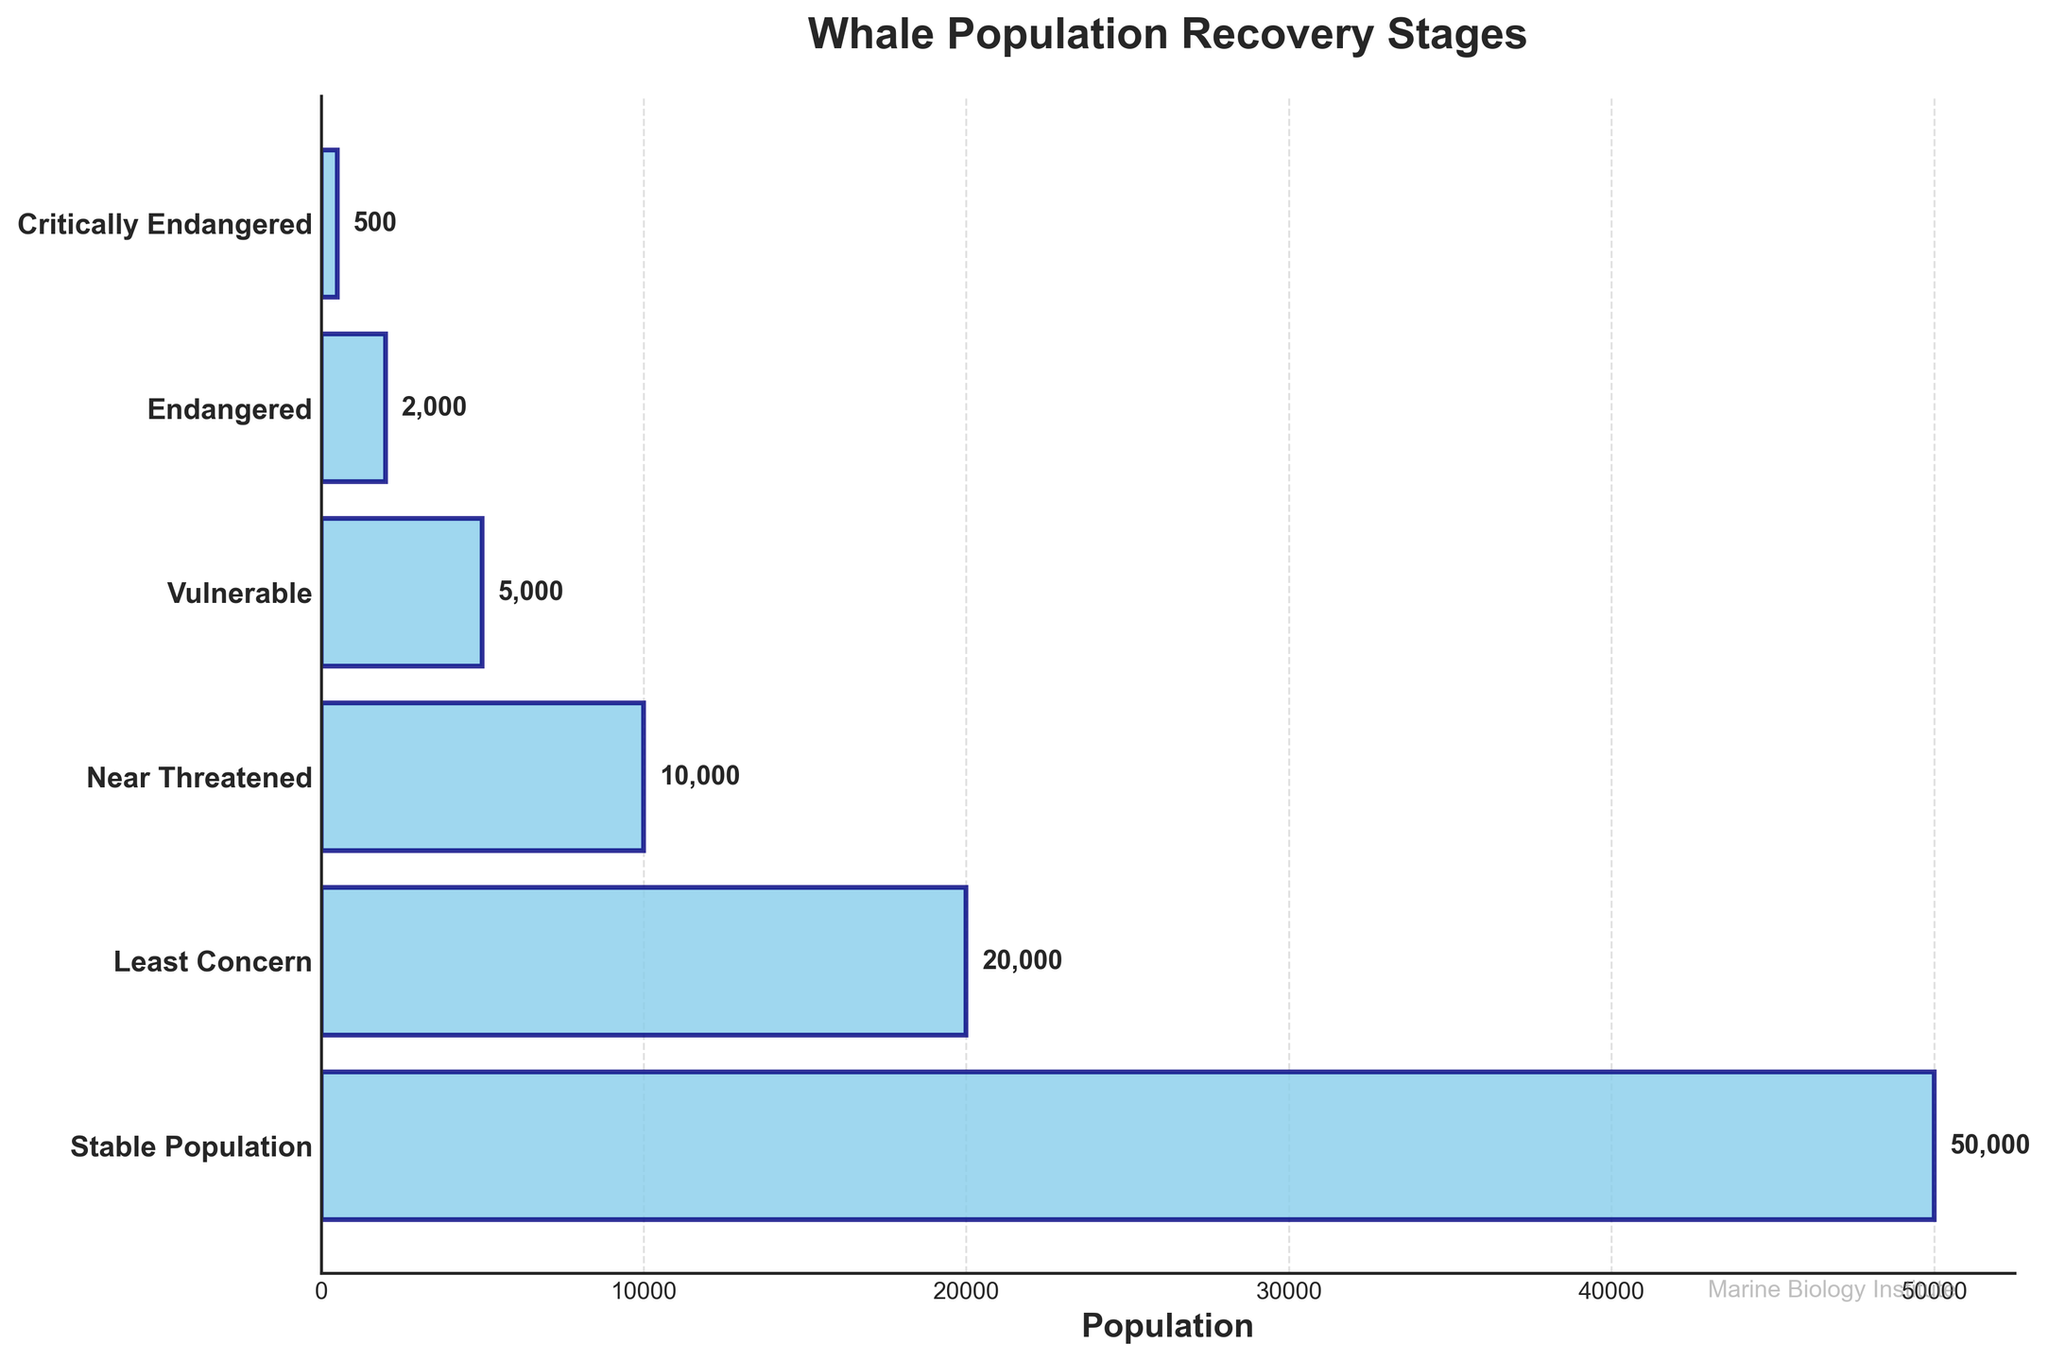What is the title of the figure? The title of the figure is typically mentioned at the top center of the plot. In this case, it is located at the top and reads 'Whale Population Recovery Stages.'
Answer: Whale Population Recovery Stages What is the population size at the ‘Critically Endangered’ stage? To find the population size at the 'Critically Endangered' stage, look at the first bar at the top of the funnel chart, which represents this stage and has a population label next to it.
Answer: 500 What stage has a population of 20,000? Look at the labels beside the bars and find the bar with the population value of 20,000. The corresponding stage label is to the left of this bar.
Answer: Least Concern What is the total whale population from Endangered to Near Threatened stages? Sum the populations of the 'Endangered,' 'Vulnerable,' and 'Near Threatened' stages: 2000 (Endangered) + 5000 (Vulnerable) + 10000 (Near Threatened) = 17,000.
Answer: 17,000 How much greater is the population in the 'Stable Population' stage compared to the 'Vulnerable' stage? Subtract the population of the 'Vulnerable' stage from the population of the 'Stable Population' stage: 50,000 (Stable Population) - 5,000 (Vulnerable) = 45,000.
Answer: 45,000 What is the average population size across all the stages? Sum the populations from all stages and divide by the number of stages: (500 + 2000 + 5000 + 10000 + 20000 + 50000) / 6 = 87500 / 6 ≈ 14583.33.
Answer: 14,583 Which stage comes immediately after the 'Vulnerable' stage in terms of increasing population size? Identify the stage listed directly below the 'Vulnerable' stage on the y-axis.
Answer: Near Threatened What is the width proportion of the ‘Endangered’ stage compared to the ‘Stable Population’ stage? Divide the population of the 'Endangered' stage by the population of the 'Stable Population' stage: 2000 / 50000 = 0.04.
Answer: 0.04 